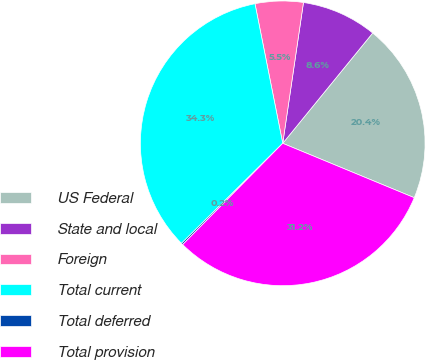Convert chart to OTSL. <chart><loc_0><loc_0><loc_500><loc_500><pie_chart><fcel>US Federal<fcel>State and local<fcel>Foreign<fcel>Total current<fcel>Total deferred<fcel>Total provision<nl><fcel>20.35%<fcel>8.56%<fcel>5.45%<fcel>34.28%<fcel>0.19%<fcel>31.16%<nl></chart> 